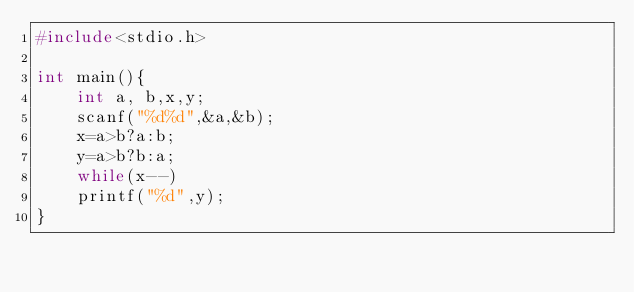Convert code to text. <code><loc_0><loc_0><loc_500><loc_500><_C_>#include<stdio.h>  

int main(){
	int a, b,x,y;
	scanf("%d%d",&a,&b);
	x=a>b?a:b;
	y=a>b?b:a;
	while(x--)
	printf("%d",y); 
}</code> 